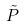Convert formula to latex. <formula><loc_0><loc_0><loc_500><loc_500>\tilde { P }</formula> 